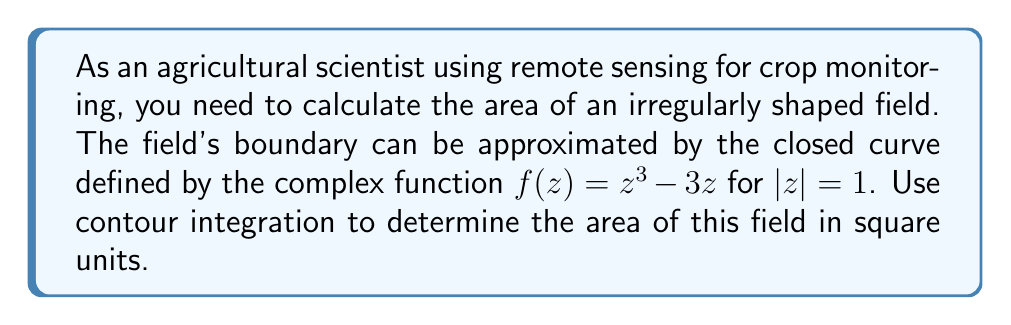Could you help me with this problem? To solve this problem, we'll use Green's theorem in the complex plane, which relates a line integral around a simple closed curve to a double integral over the plane region it encloses.

1) The area of a region enclosed by a simple closed curve $C$ can be calculated using the formula:

   $$A = -\frac{1}{2i} \oint_C z \, d\bar{z}$$

   where $\bar{z}$ is the complex conjugate of $z$.

2) In our case, the curve $C$ is defined by $f(z) = z^3 - 3z$ for $|z| = 1$. We need to parameterize this curve.

3) Let $z = e^{it}$ for $0 \leq t \leq 2\pi$. Then $dz = ie^{it}dt$.

4) Substituting into the area formula:

   $$A = -\frac{1}{2i} \oint_C f(z) \, d\bar{f(z)}$$

5) We need to calculate $d\bar{f(z)}$:
   
   $$\bar{f(z)} = \bar{z}^3 - 3\bar{z}$$
   $$d\bar{f(z)} = (3\bar{z}^2 - 3)d\bar{z} = (3e^{-2it} - 3)(-ie^{-it})dt = i(3e^{-3it} - 3e^{-it})dt$$

6) Now, we can set up our integral:

   $$A = -\frac{1}{2i} \int_0^{2\pi} (e^{3it} - 3e^{it}) \cdot i(3e^{-3it} - 3e^{-it})dt$$

7) Expanding this:

   $$A = -\frac{1}{2i} \int_0^{2\pi} (3i - 3ie^{2it} - 3ie^{-2it} + 3i)dt$$

8) Simplifying:

   $$A = -\frac{1}{2i} \int_0^{2\pi} (6i - 3i(e^{2it} + e^{-2it}))dt$$

9) Using Euler's formula, $e^{2it} + e^{-2it} = 2\cos(2t)$:

   $$A = -\frac{1}{2i} \int_0^{2\pi} (6i - 6i\cos(2t))dt = 3 \int_0^{2\pi} (1 - \cos(2t))dt$$

10) Evaluating this integral:

    $$A = 3 [t - \frac{1}{2}\sin(2t)]_0^{2\pi} = 3(2\pi - 0) = 6\pi$$

Therefore, the area of the field is $6\pi$ square units.
Answer: $6\pi$ square units 